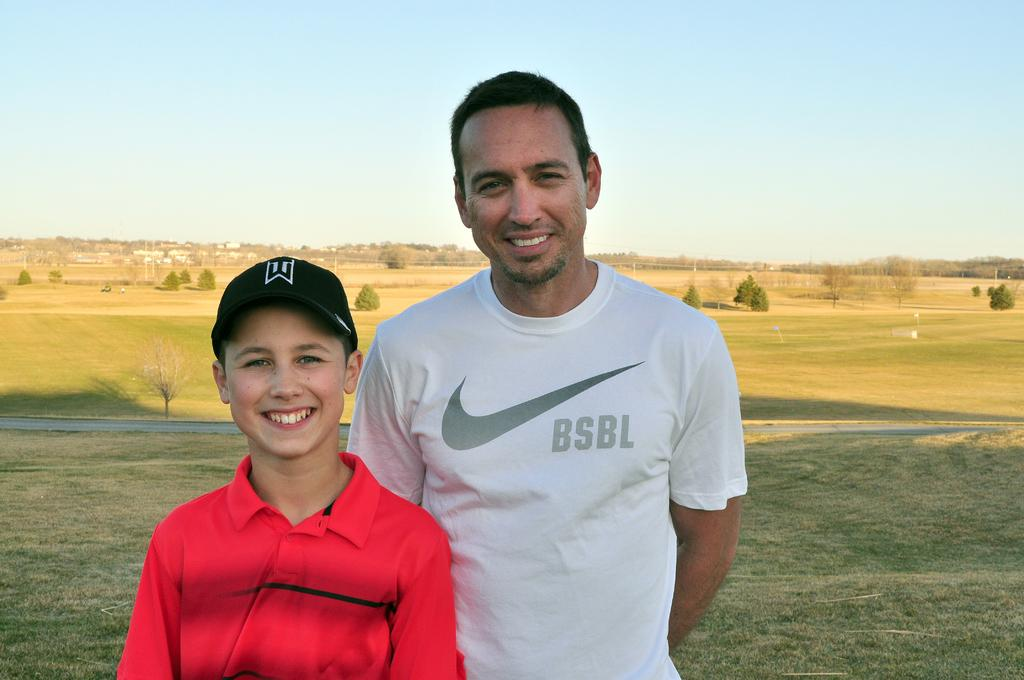How many people are in the image? There are two people in the image. What is the setting of the image? The people are standing in an open ground. Can you describe the clothing of the person wearing a cap? The person wearing a cap is also wearing a red shirt. What is the other person wearing? The other person is wearing a white t-shirt. How many passengers are sitting on the scarecrow in the image? There is no scarecrow or passengers present in the image. 